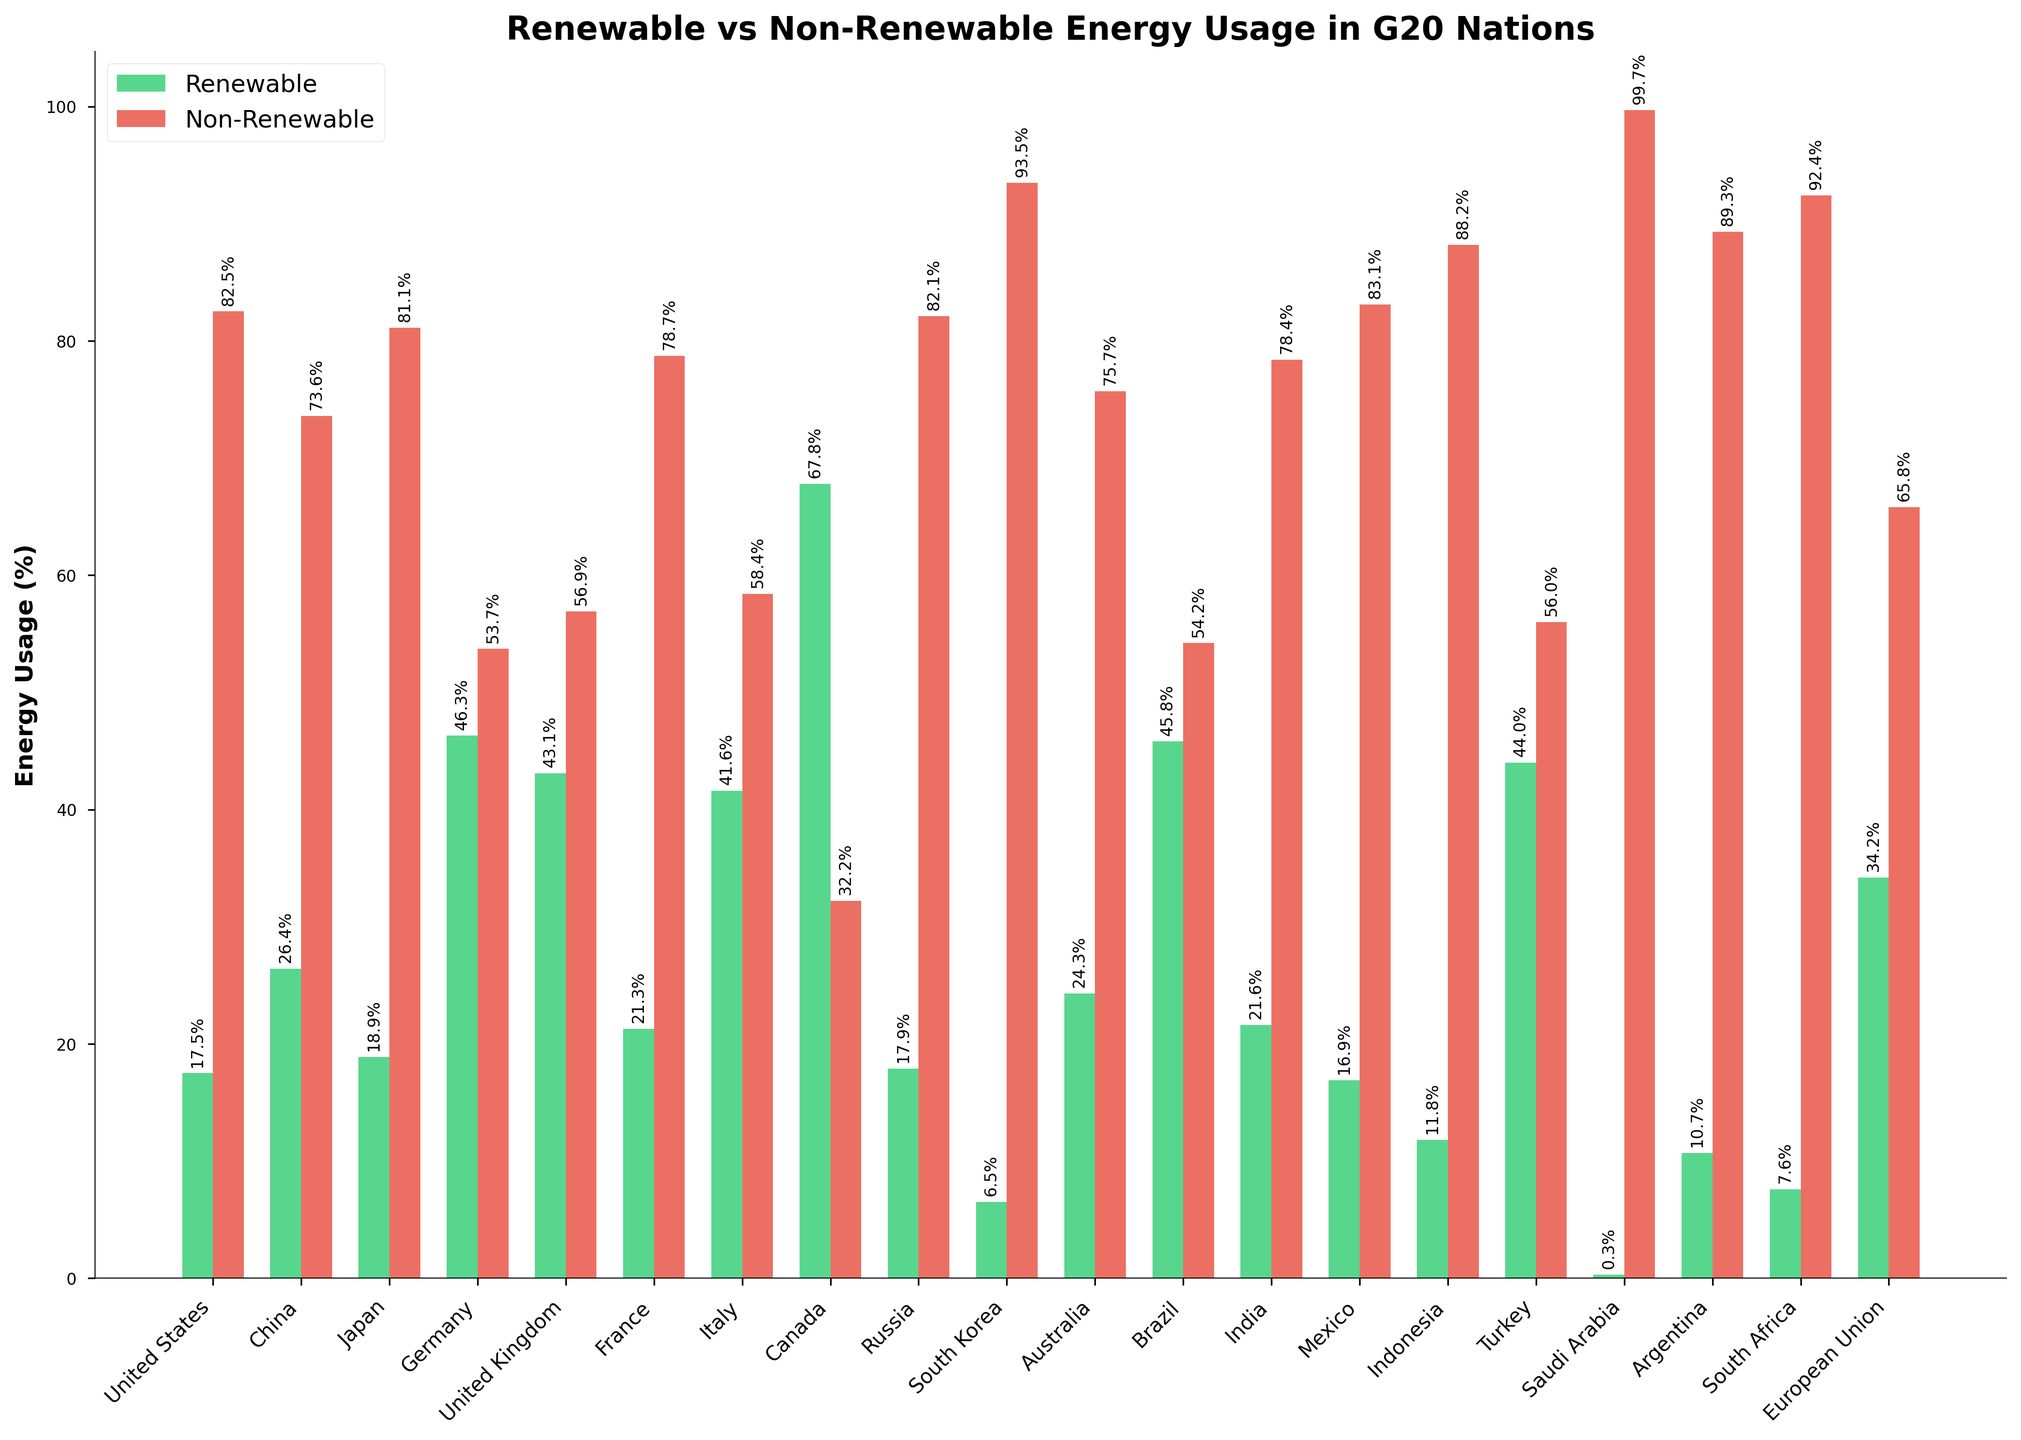Which country uses the most renewable energy in terms of percentage? By examining the heights of the green bars, we can identify the country with the highest bar. Canada has the tallest green bar representing 67.8%.
Answer: Canada Which country has the lowest percentage of renewable energy usage? By looking for the shortest green bar, we find that Saudi Arabia has the lowest percentage with only 0.3%.
Answer: Saudi Arabia Compare the renewable energy usage between Germany and the United Kingdom. Which country uses more, and by how much? Germany's renewable energy usage is 46.3%, and the United Kingdom's is 43.1%. The difference is 46.3% - 43.1% = 3.2%. So, Germany uses 3.2% more renewable energy than the United Kingdom.
Answer: Germany by 3.2% Which G20 nation has the highest non-renewable energy usage, and what is its percentage? The tallest red bar represents the highest non-renewable energy usage. Saudi Arabia has the tallest red bar at 99.7%.
Answer: Saudi Arabia, 99.7% What is the average percentage of renewable energy usage across all G20 nations? Sum all the percentages of renewable energy usage and divide by the number of countries: (17.5 + 26.4 + 18.9 + 46.3 + 43.1 + 21.3 + 41.6 + 67.8 + 17.9 + 6.5 + 24.3 + 45.8 + 21.6 + 16.9 + 11.8 + 44.0 + 0.3 + 10.7 + 7.6 + 34.2) / 20 = 25.01%.
Answer: 25.01% Which two countries have the closest percentages of renewable and non-renewable energy usages? By looking at the visual proximity of green and red bar heights, Germany and Brazil have the closest renewable to non-renewable energy usage percentages (46.3% renewable vs. 53.7% non-renewable and 45.8% renewable vs. 54.2% non-renewable, respectively).
Answer: Germany and Brazil To what extent does Russia rely on non-renewable energy compared to renewable energy? Russia uses 82.1% non-renewable and 17.9% renewable energy. Subtract the renewable percentage from the non-renewable percentage: 82.1% - 17.9% = 64.2%. Russia relies 64.2% more on non-renewable energy.
Answer: 64.2% more What is the combined renewable energy usage of the top three countries with the highest renewable percentages? The top three countries with the highest renewable percentages are Canada (67.8%), Germany (46.3%), and Brazil (45.8%). Sum these values: 67.8% + 46.3% + 45.8% = 159.9%.
Answer: 159.9% Which country has a more balanced energy usage between renewable and non-renewable sources, and what are the percentages? A more balanced usage would mean the green and red bars are nearly equal in height. Germany (46.3% renewable and 53.7% non-renewable) has the most balanced energy usage.
Answer: Germany, 46.3% renewable, 53.7% non-renewable 